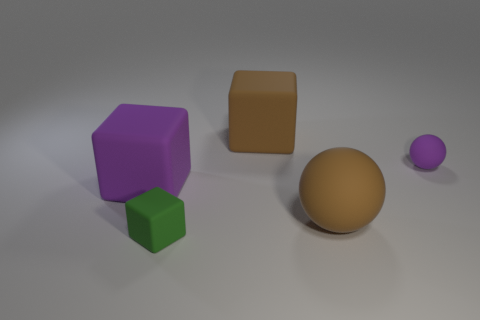How many things are either purple blocks or green matte objects?
Provide a short and direct response. 2. The green object has what shape?
Your answer should be compact. Cube. The green matte thing that is the same shape as the big purple object is what size?
Offer a very short reply. Small. There is a matte ball that is to the right of the brown matte thing that is in front of the big brown block; how big is it?
Make the answer very short. Small. Are there an equal number of small purple matte objects that are left of the brown block and tiny green rubber cylinders?
Ensure brevity in your answer.  Yes. What number of other objects are there of the same color as the tiny matte ball?
Give a very brief answer. 1. Is the number of purple objects to the left of the big matte sphere less than the number of rubber balls?
Provide a succinct answer. Yes. Are there any green rubber cubes that have the same size as the purple sphere?
Offer a terse response. Yes. Does the tiny cube have the same color as the large block to the left of the green matte thing?
Provide a short and direct response. No. What number of tiny green objects are to the right of the small rubber object that is right of the tiny block?
Make the answer very short. 0. 